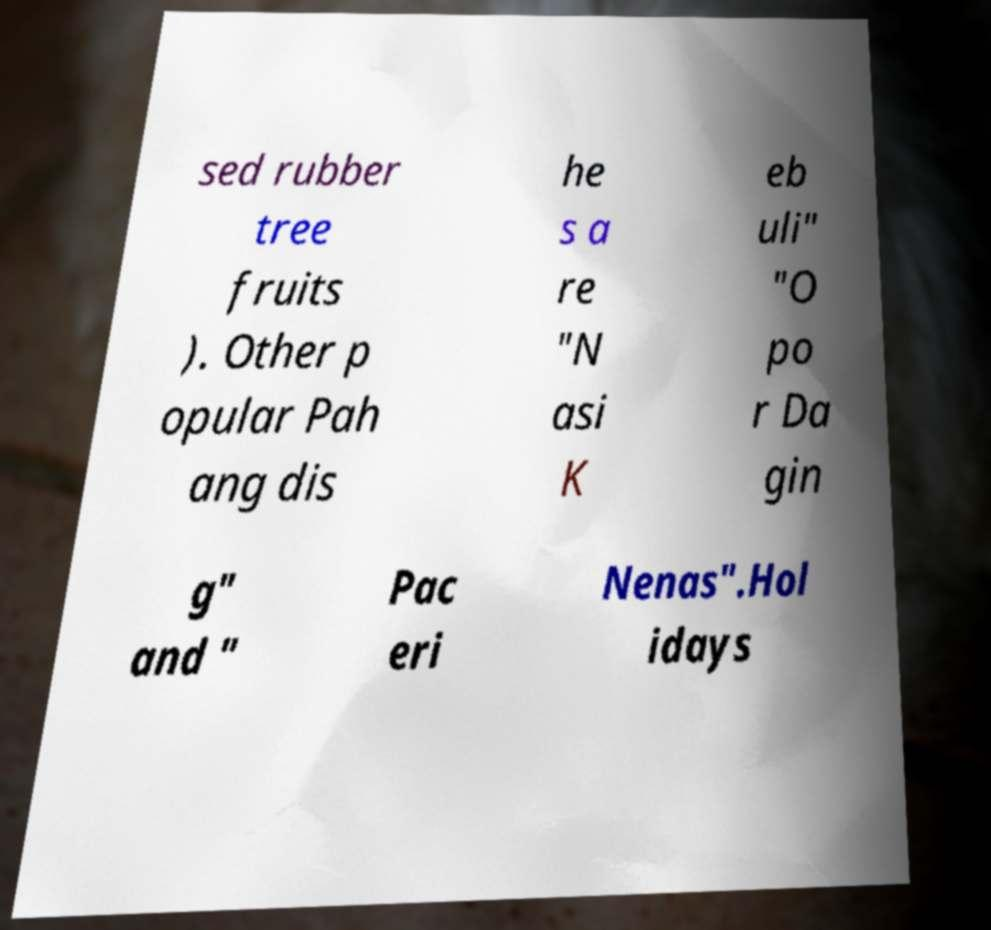Please read and relay the text visible in this image. What does it say? sed rubber tree fruits ). Other p opular Pah ang dis he s a re "N asi K eb uli" "O po r Da gin g" and " Pac eri Nenas".Hol idays 